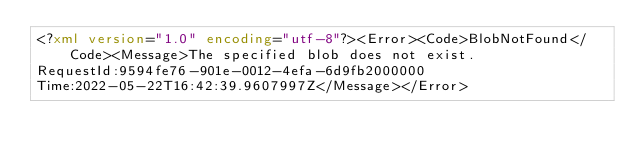<code> <loc_0><loc_0><loc_500><loc_500><_XML_><?xml version="1.0" encoding="utf-8"?><Error><Code>BlobNotFound</Code><Message>The specified blob does not exist.
RequestId:9594fe76-901e-0012-4efa-6d9fb2000000
Time:2022-05-22T16:42:39.9607997Z</Message></Error></code> 